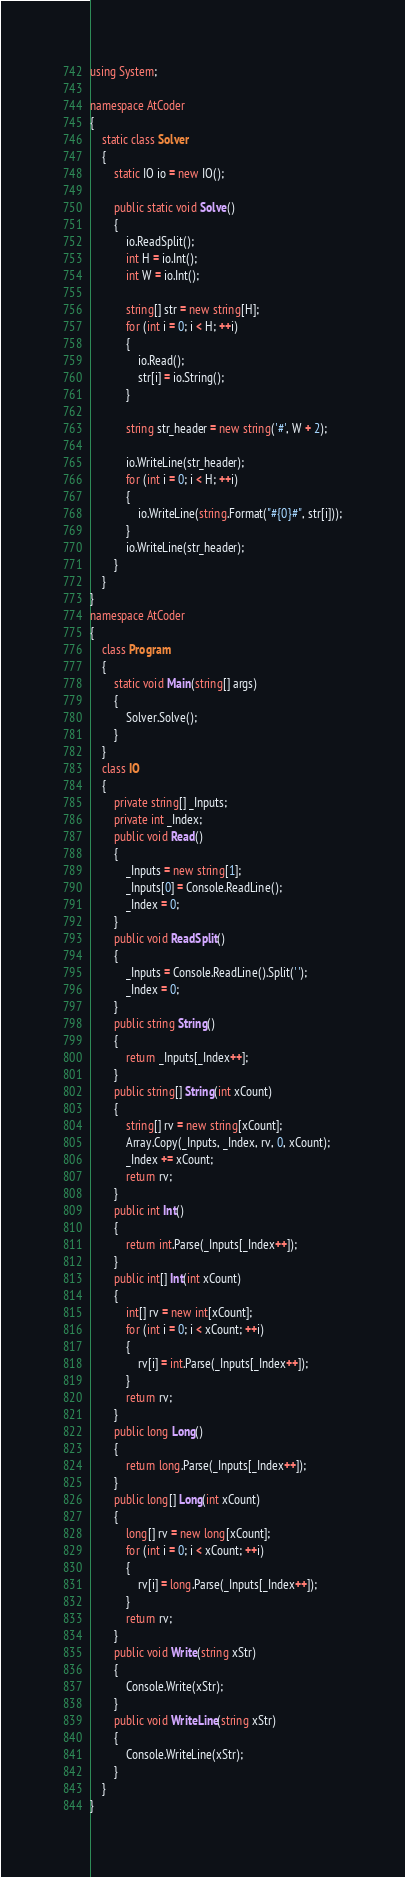<code> <loc_0><loc_0><loc_500><loc_500><_C#_>using System;

namespace AtCoder
{
    static class Solver
    {
        static IO io = new IO();

        public static void Solve()
        {
            io.ReadSplit();
            int H = io.Int();
            int W = io.Int();

            string[] str = new string[H];
            for (int i = 0; i < H; ++i)
            {
                io.Read();
                str[i] = io.String();
            }

            string str_header = new string('#', W + 2);

            io.WriteLine(str_header);
            for (int i = 0; i < H; ++i)
            {
                io.WriteLine(string.Format("#{0}#", str[i]));
            }
            io.WriteLine(str_header);
        }
    }
}
namespace AtCoder
{
    class Program
    {
        static void Main(string[] args)
        {
            Solver.Solve();
        }
    }
    class IO
    {
        private string[] _Inputs;
        private int _Index;
        public void Read()
        {
            _Inputs = new string[1];
            _Inputs[0] = Console.ReadLine();
            _Index = 0;
        }
        public void ReadSplit()
        {
            _Inputs = Console.ReadLine().Split(' ');
            _Index = 0;
        }
        public string String()
        {
            return _Inputs[_Index++];
        }
        public string[] String(int xCount)
        {
            string[] rv = new string[xCount];
            Array.Copy(_Inputs, _Index, rv, 0, xCount);
            _Index += xCount;
            return rv;
        }
        public int Int()
        {
            return int.Parse(_Inputs[_Index++]);
        }
        public int[] Int(int xCount)
        {
            int[] rv = new int[xCount];
            for (int i = 0; i < xCount; ++i)
            {
                rv[i] = int.Parse(_Inputs[_Index++]);
            }
            return rv;
        }
        public long Long()
        {
            return long.Parse(_Inputs[_Index++]);
        }
        public long[] Long(int xCount)
        {
            long[] rv = new long[xCount];
            for (int i = 0; i < xCount; ++i)
            {
                rv[i] = long.Parse(_Inputs[_Index++]);
            }
            return rv;
        }
        public void Write(string xStr)
        {
            Console.Write(xStr);
        }
        public void WriteLine(string xStr)
        {
            Console.WriteLine(xStr);
        }
    }
}</code> 